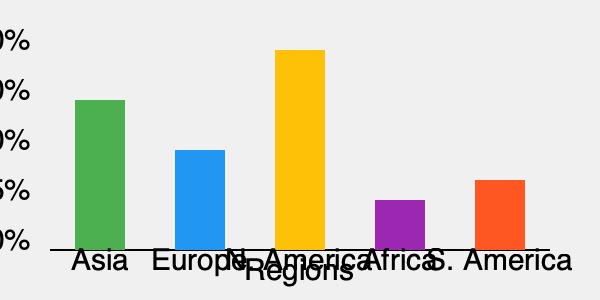Analyzing the geographical distribution of international students in U.S. higher education institutions, which region shows the highest percentage of international student enrollment, and how might this impact higher education policies and international relations? To answer this question, we need to analyze the graph and consider its implications for higher education policies and international relations:

1. Interpret the graph:
   - The graph shows the percentage of international students from different regions enrolled in U.S. higher education institutions.
   - The y-axis represents the percentage of students, while the x-axis shows different world regions.

2. Identify the region with the highest percentage:
   - Asia has the tallest bar, reaching approximately 50% on the y-axis.
   - North America is the second-highest, followed by Europe, South America, and Africa.

3. Consider the impact on higher education policies:
   a) Curriculum development:
      - Increased focus on cross-cultural competencies
      - Potential for more diverse language offerings
   b) Support services:
      - Enhanced international student offices
      - Cultural adaptation programs
   c) Admissions policies:
      - Targeted recruitment strategies for underrepresented regions
      - Potential changes in visa and immigration policies

4. Analyze the impact on international relations:
   a) Soft power and cultural diplomacy:
      - Strengthened ties with Asian countries through educational exchanges
      - Potential for improved long-term diplomatic relations
   b) Economic implications:
      - Increased revenue from international student tuition
      - Potential for future business and trade partnerships
   c) Brain drain/gain dynamics:
      - Possible concerns from Asian countries about talent outflow
      - Opportunity for knowledge transfer and capacity building

5. Consider policy implications:
   a) Diversity and inclusion initiatives to support integration
   b) Bilateral agreements to facilitate student mobility
   c) Research collaborations focusing on Asian partnerships
   d) Strategies to balance regional representation in international student populations
Answer: Asia; impacts include curriculum diversification, enhanced support services, targeted admissions policies, strengthened diplomatic ties with Asian countries, and increased focus on cross-cultural competencies in higher education. 